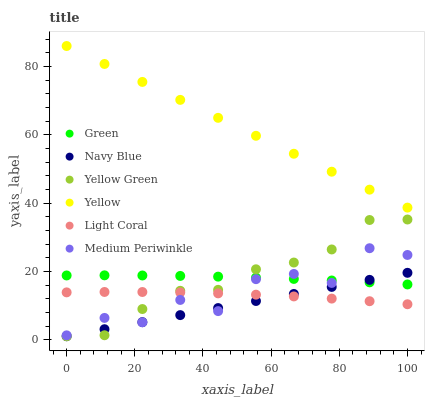Does Navy Blue have the minimum area under the curve?
Answer yes or no. Yes. Does Yellow have the maximum area under the curve?
Answer yes or no. Yes. Does Medium Periwinkle have the minimum area under the curve?
Answer yes or no. No. Does Medium Periwinkle have the maximum area under the curve?
Answer yes or no. No. Is Navy Blue the smoothest?
Answer yes or no. Yes. Is Medium Periwinkle the roughest?
Answer yes or no. Yes. Is Medium Periwinkle the smoothest?
Answer yes or no. No. Is Navy Blue the roughest?
Answer yes or no. No. Does Yellow Green have the lowest value?
Answer yes or no. Yes. Does Medium Periwinkle have the lowest value?
Answer yes or no. No. Does Yellow have the highest value?
Answer yes or no. Yes. Does Navy Blue have the highest value?
Answer yes or no. No. Is Navy Blue less than Yellow?
Answer yes or no. Yes. Is Yellow greater than Navy Blue?
Answer yes or no. Yes. Does Yellow Green intersect Medium Periwinkle?
Answer yes or no. Yes. Is Yellow Green less than Medium Periwinkle?
Answer yes or no. No. Is Yellow Green greater than Medium Periwinkle?
Answer yes or no. No. Does Navy Blue intersect Yellow?
Answer yes or no. No. 